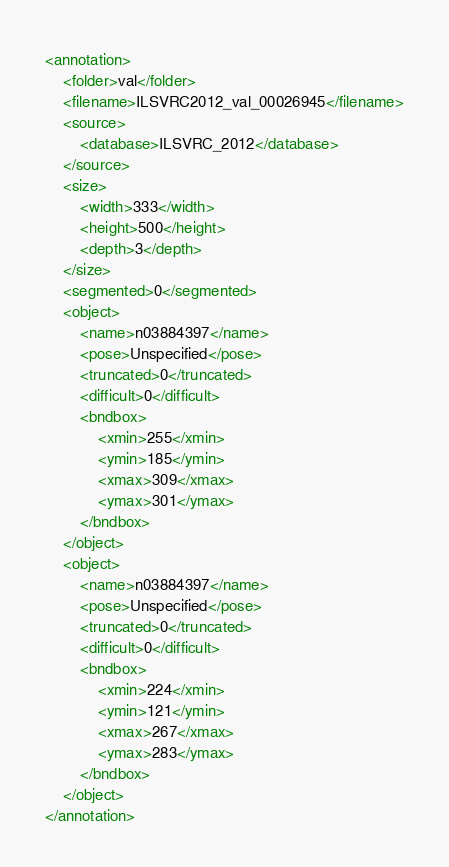Convert code to text. <code><loc_0><loc_0><loc_500><loc_500><_XML_><annotation>
	<folder>val</folder>
	<filename>ILSVRC2012_val_00026945</filename>
	<source>
		<database>ILSVRC_2012</database>
	</source>
	<size>
		<width>333</width>
		<height>500</height>
		<depth>3</depth>
	</size>
	<segmented>0</segmented>
	<object>
		<name>n03884397</name>
		<pose>Unspecified</pose>
		<truncated>0</truncated>
		<difficult>0</difficult>
		<bndbox>
			<xmin>255</xmin>
			<ymin>185</ymin>
			<xmax>309</xmax>
			<ymax>301</ymax>
		</bndbox>
	</object>
	<object>
		<name>n03884397</name>
		<pose>Unspecified</pose>
		<truncated>0</truncated>
		<difficult>0</difficult>
		<bndbox>
			<xmin>224</xmin>
			<ymin>121</ymin>
			<xmax>267</xmax>
			<ymax>283</ymax>
		</bndbox>
	</object>
</annotation></code> 